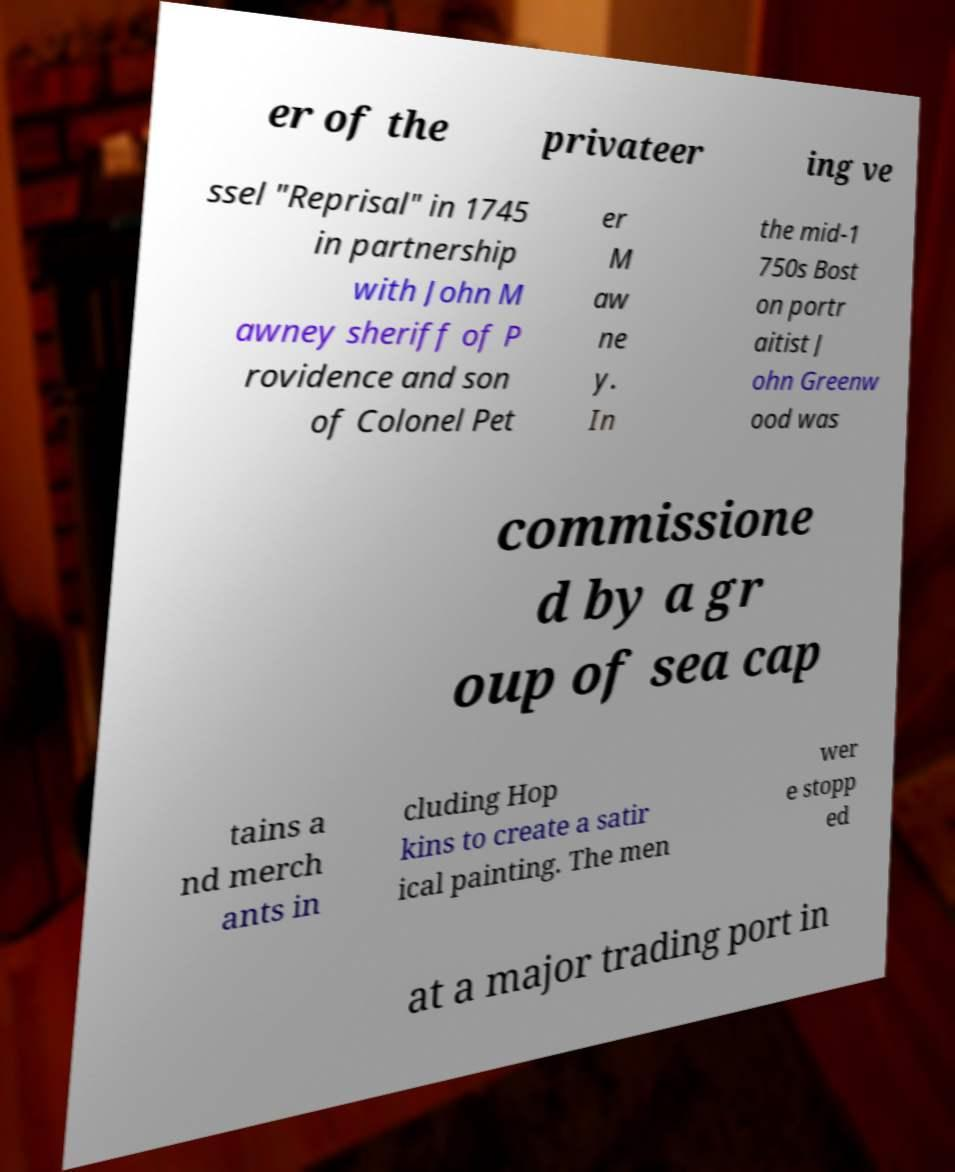Please identify and transcribe the text found in this image. er of the privateer ing ve ssel "Reprisal" in 1745 in partnership with John M awney sheriff of P rovidence and son of Colonel Pet er M aw ne y. In the mid-1 750s Bost on portr aitist J ohn Greenw ood was commissione d by a gr oup of sea cap tains a nd merch ants in cluding Hop kins to create a satir ical painting. The men wer e stopp ed at a major trading port in 